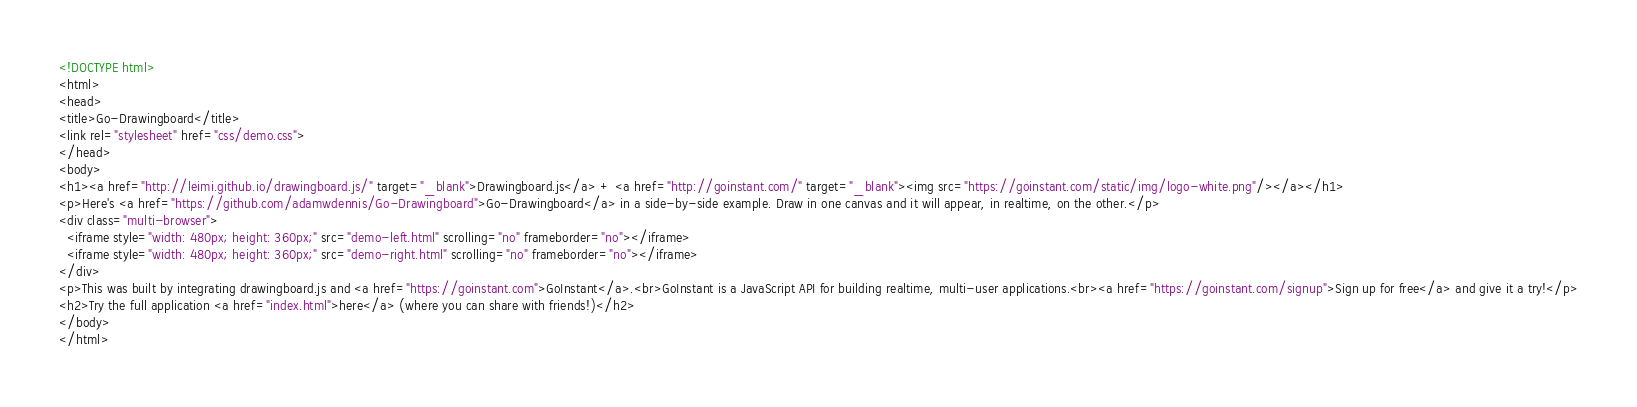<code> <loc_0><loc_0><loc_500><loc_500><_HTML_><!DOCTYPE html>
<html>
<head>
<title>Go-Drawingboard</title>
<link rel="stylesheet" href="css/demo.css">
</head>
<body>
<h1><a href="http://leimi.github.io/drawingboard.js/" target="_blank">Drawingboard.js</a> + <a href="http://goinstant.com/" target="_blank"><img src="https://goinstant.com/static/img/logo-white.png"/></a></h1>
<p>Here's <a href="https://github.com/adamwdennis/Go-Drawingboard">Go-Drawingboard</a> in a side-by-side example. Draw in one canvas and it will appear, in realtime, on the other.</p>
<div class="multi-browser">
  <iframe style="width: 480px; height: 360px;" src="demo-left.html" scrolling="no" frameborder="no"></iframe>
  <iframe style="width: 480px; height: 360px;" src="demo-right.html" scrolling="no" frameborder="no"></iframe>
</div>
<p>This was built by integrating drawingboard.js and <a href="https://goinstant.com">GoInstant</a>.<br>GoInstant is a JavaScript API for building realtime, multi-user applications.<br><a href="https://goinstant.com/signup">Sign up for free</a> and give it a try!</p>
<h2>Try the full application <a href="index.html">here</a> (where you can share with friends!)</h2>
</body>
</html>
</code> 